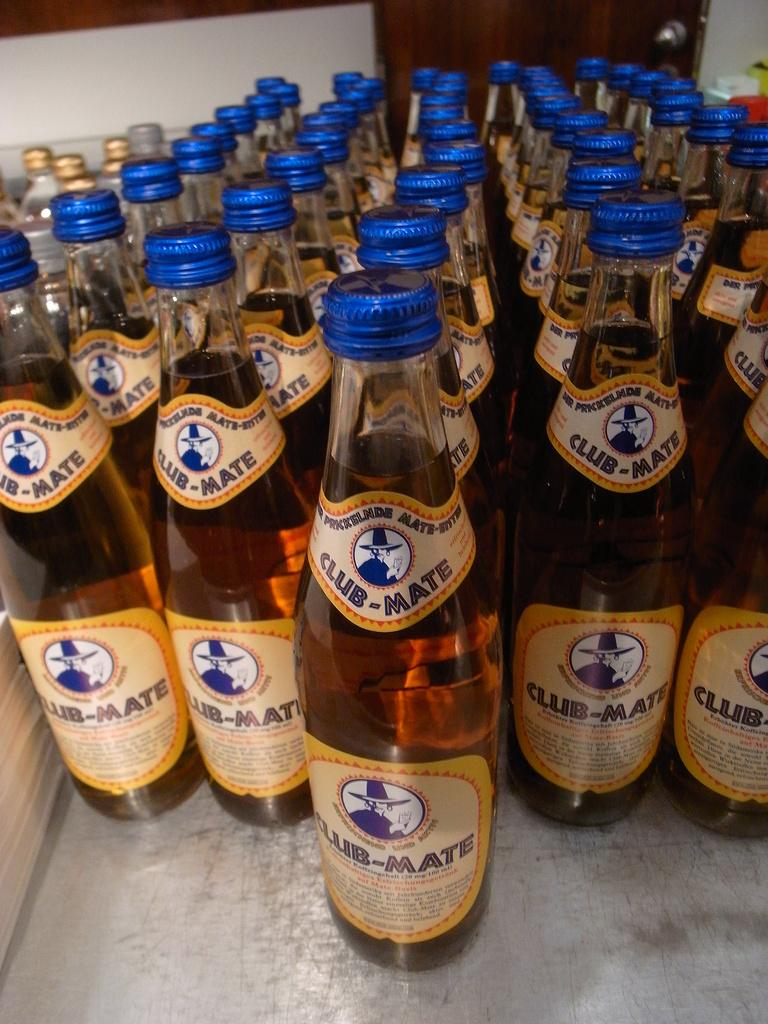<image>
Give a short and clear explanation of the subsequent image. Several bottles of Club-Mate with blue lids are grouped together. 